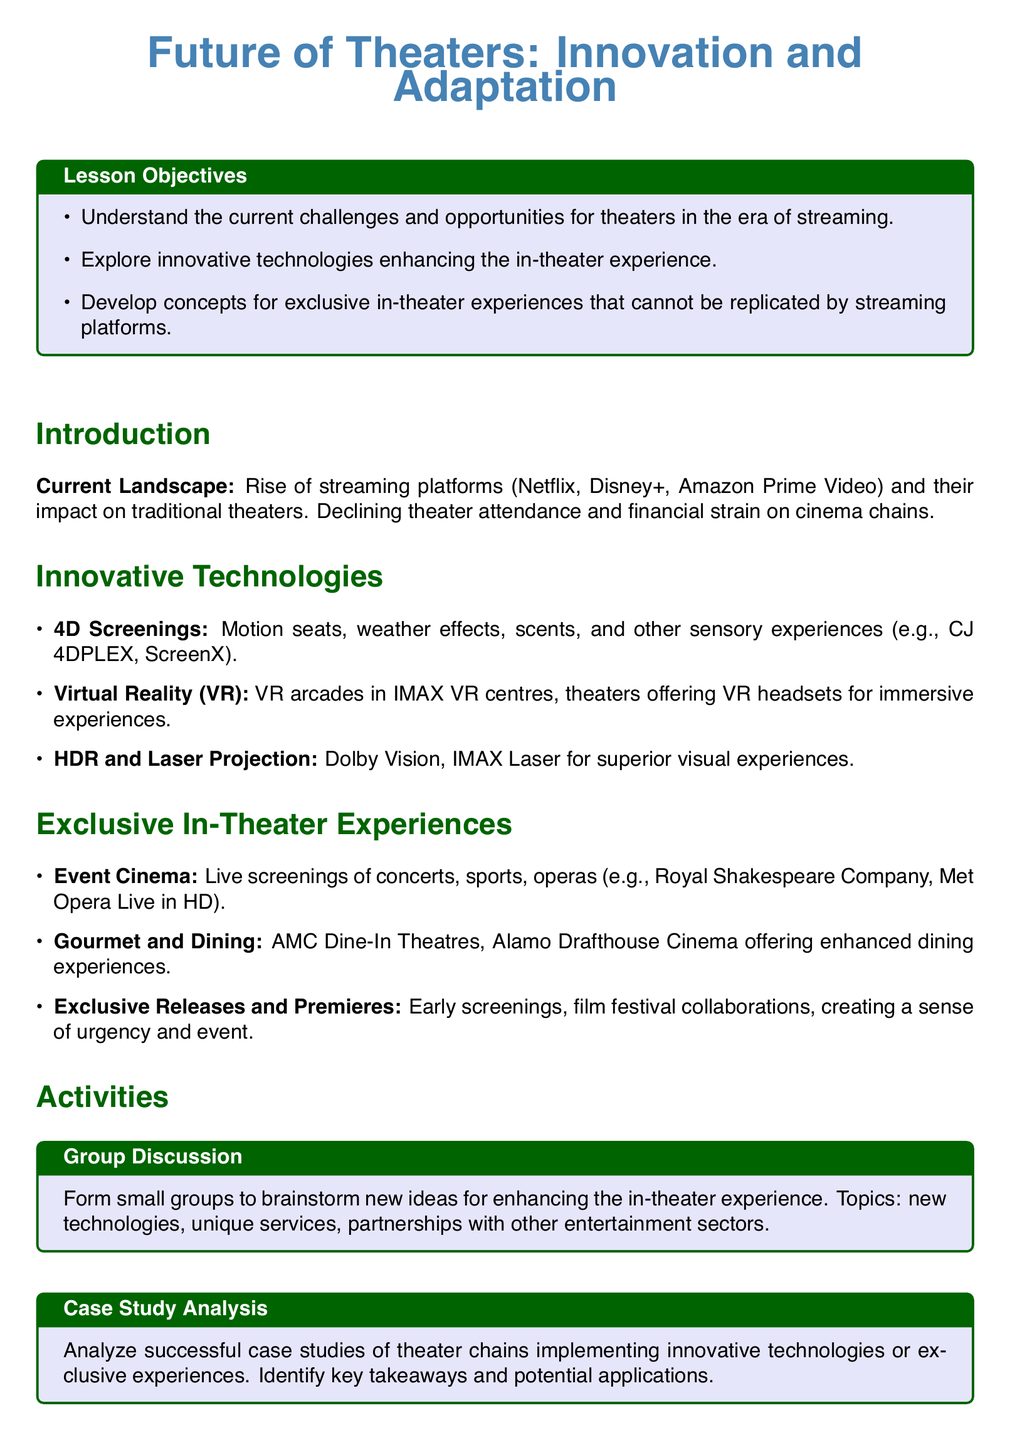What are the names of two prominent streaming platforms mentioned? The document lists Netflix and Disney+ as examples of prominent streaming platforms impacting traditional theaters.
Answer: Netflix, Disney+ What technology offers sensory experiences like motion seats and weather effects? The document refers to 4D Screenings as a technology that provides sensory experiences.
Answer: 4D Screenings What is an example of an exclusive in-theater experience mentioned? The document provides "Event Cinema" as one example of exclusive in-theater experiences, which includes live screenings of concerts and sports.
Answer: Event Cinema What is one type of projection technology that enhances the visual experience in theaters? The document mentions HDR and Laser Projection, specifically naming Dolby Vision and IMAX Laser as technologies that enhance visual experiences.
Answer: Dolby Vision What activity involves small groups brainstorming new ideas? The document describes a "Group Discussion" as an activity focused on brainstorming for enhancing the in-theater experience.
Answer: Group Discussion Which type of cinema offers gourmet dining experiences? The document includes AMC Dine-In Theatres as an example of a cinema that provides gourmet dining experiences.
Answer: AMC Dine-In Theatres How does the lesson propose theaters can adapt in the streaming era? The document concludes by stating that embracing innovative technologies and exclusive experiences can help theaters adapt and thrive.
Answer: Innovative technologies, exclusive experiences 